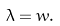Convert formula to latex. <formula><loc_0><loc_0><loc_500><loc_500>\lambda = w .</formula> 